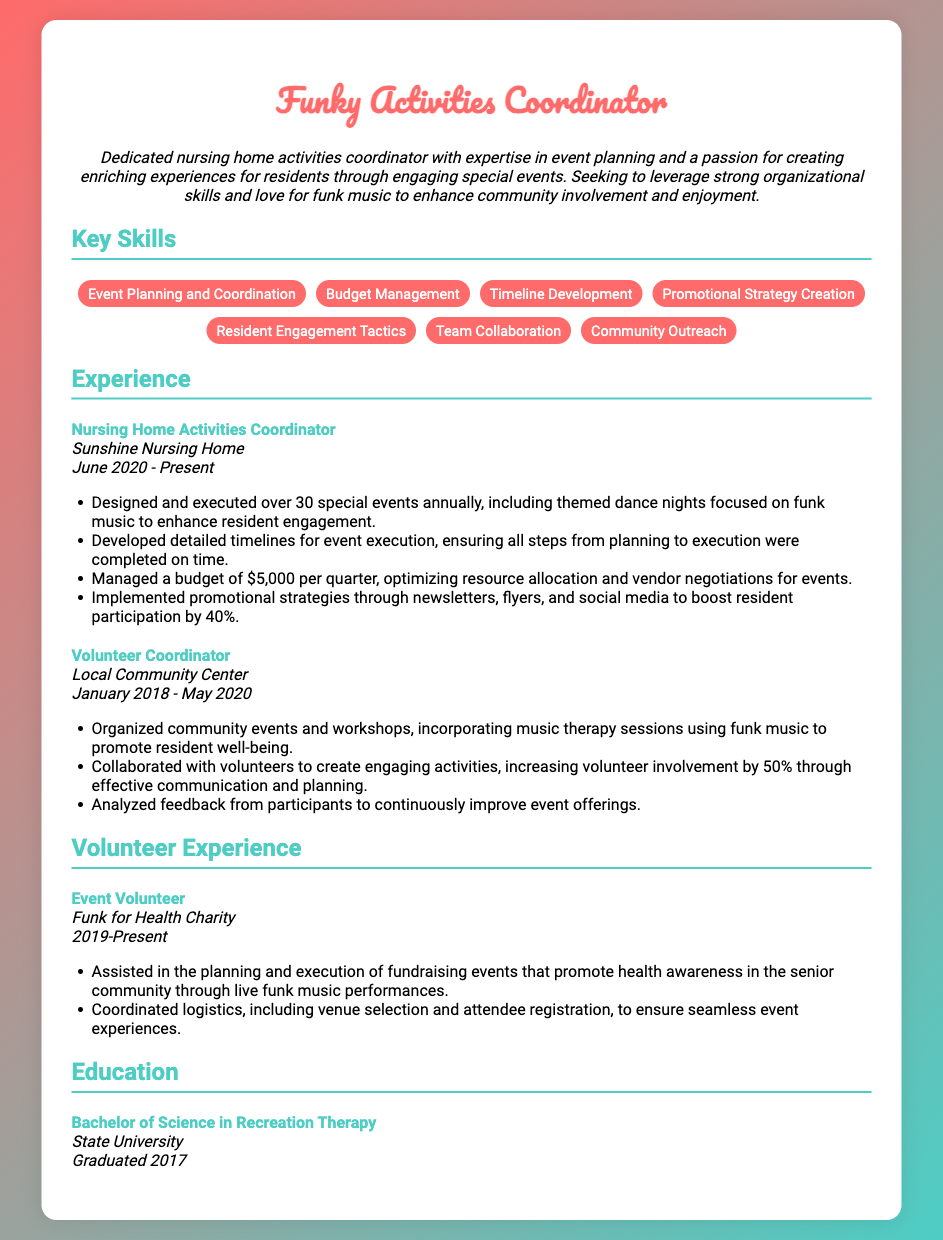what is the job title? The job title is prominently displayed at the top of the resume, indicating the specific role of the individual.
Answer: Funky Activities Coordinator where is the current workplace? The current workplace is mentioned under the experience section, specifying the organization the individual is affiliated with.
Answer: Sunshine Nursing Home how many special events are designed and executed annually? The document specifies that the candidate is involved in planning and executing a certain number of special events each year.
Answer: Over 30 what is the quarterly budget managed? The resume details the budget that the activities coordinator is responsible for on a quarterly basis.
Answer: $5,000 what type of music is incorporated into activities? The resume highlights the particular genre of music emphasized in their event activities, which reflects the coordinator's interests.
Answer: Funk music how much was the increase in resident participation? The document indicates the percentage growth in resident participation due to promotional strategies implemented by the coordinator.
Answer: 40% how long did the individual serve as a Volunteer Coordinator? The duration of service in this particular role is specified in the experience section, giving insight into the individual's background.
Answer: January 2018 - May 2020 what is the highest level of education attained? The education section of the resume outlines the degree obtained by the individual, indicating their academic achievements.
Answer: Bachelor of Science in Recreation Therapy how many events did the individual assist with for the charity? The resume mentions involvement in charity events, but does not specify the number, which is important for estimating experience.
Answer: Not specified 